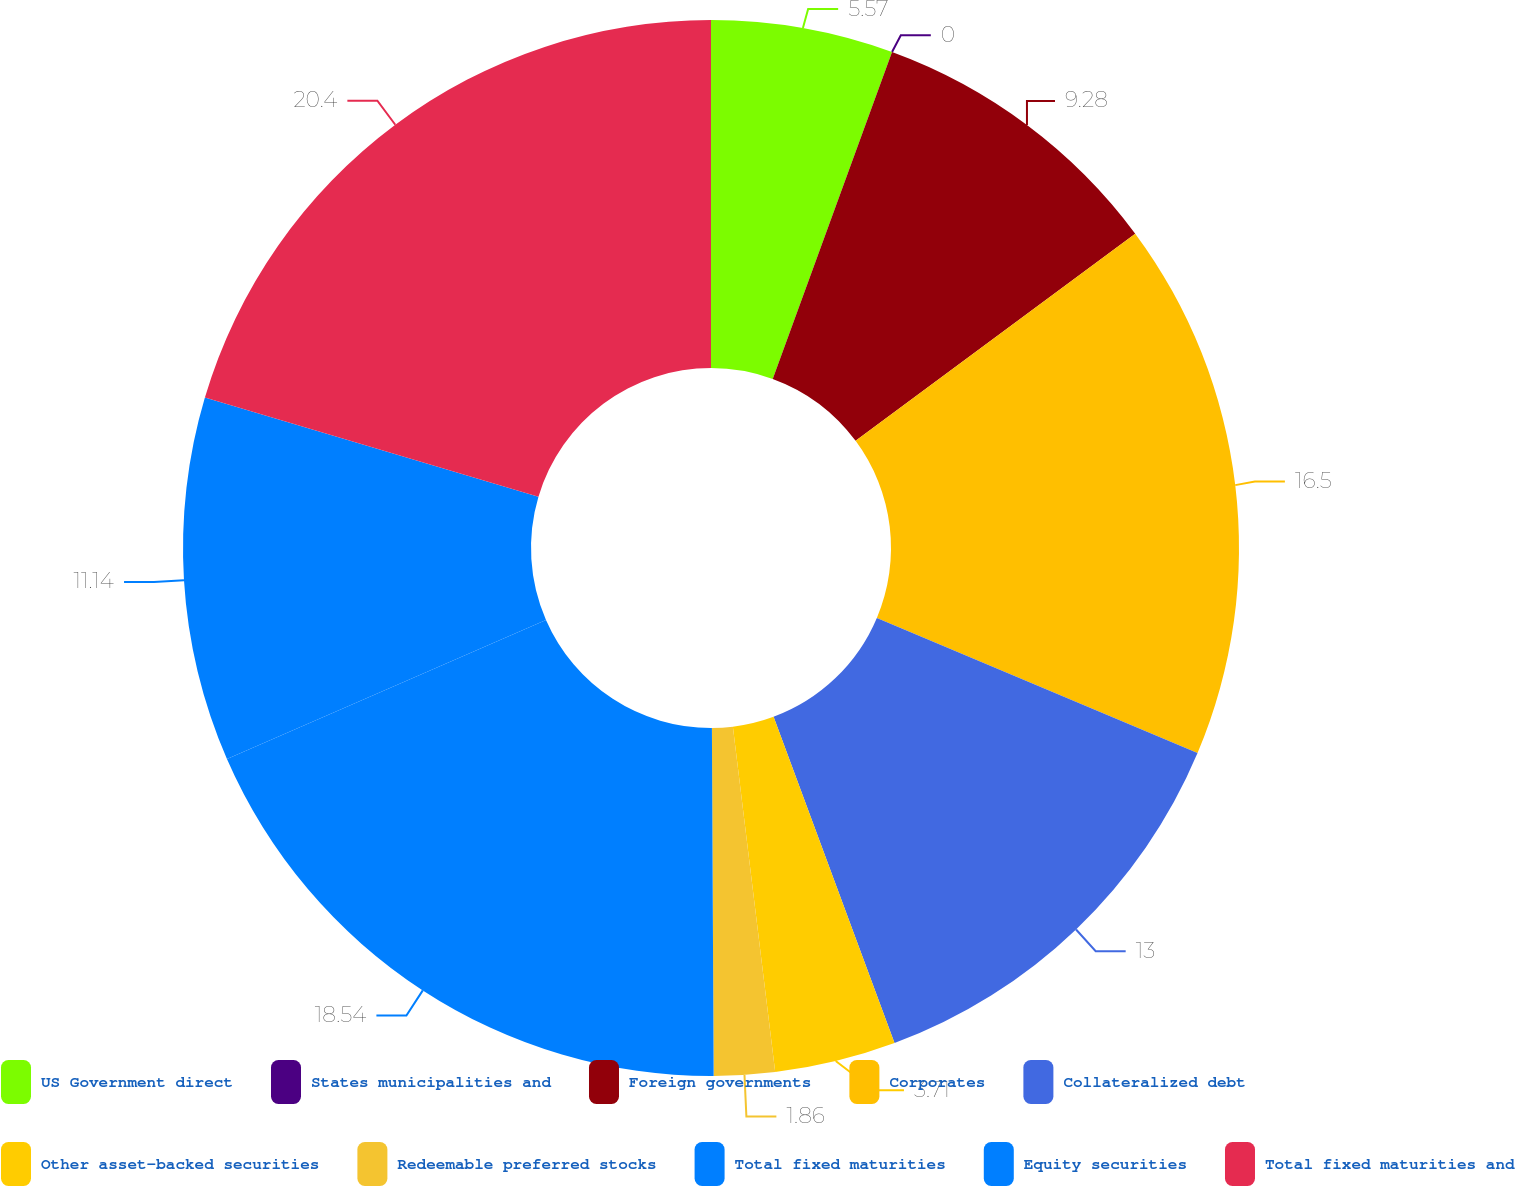<chart> <loc_0><loc_0><loc_500><loc_500><pie_chart><fcel>US Government direct<fcel>States municipalities and<fcel>Foreign governments<fcel>Corporates<fcel>Collateralized debt<fcel>Other asset-backed securities<fcel>Redeemable preferred stocks<fcel>Total fixed maturities<fcel>Equity securities<fcel>Total fixed maturities and<nl><fcel>5.57%<fcel>0.0%<fcel>9.28%<fcel>16.5%<fcel>13.0%<fcel>3.71%<fcel>1.86%<fcel>18.54%<fcel>11.14%<fcel>20.4%<nl></chart> 